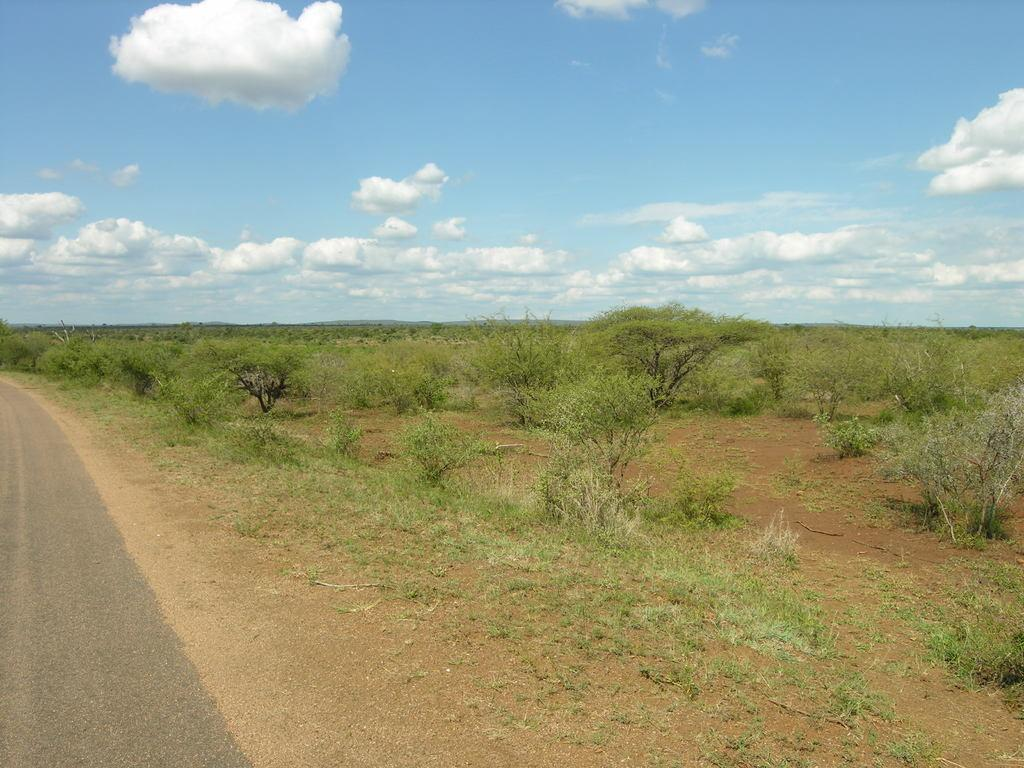What type of vegetation can be seen in the image? There are trees in the image. What else can be seen on the ground in the image? There is grass in the image. What is located on the left side of the image? There is a road on the left side of the image. What is visible at the top of the image? The sky is visible at the top of the image. What can be seen in the sky in the image? Clouds are present in the sky. What type of sack can be seen hanging from the trees in the image? There is no sack present in the image; it only features trees, grass, a road, the sky, and clouds. What type of lace is used to decorate the grass in the image? There is no lace present in the image; the grass is not decorated with any lace. 